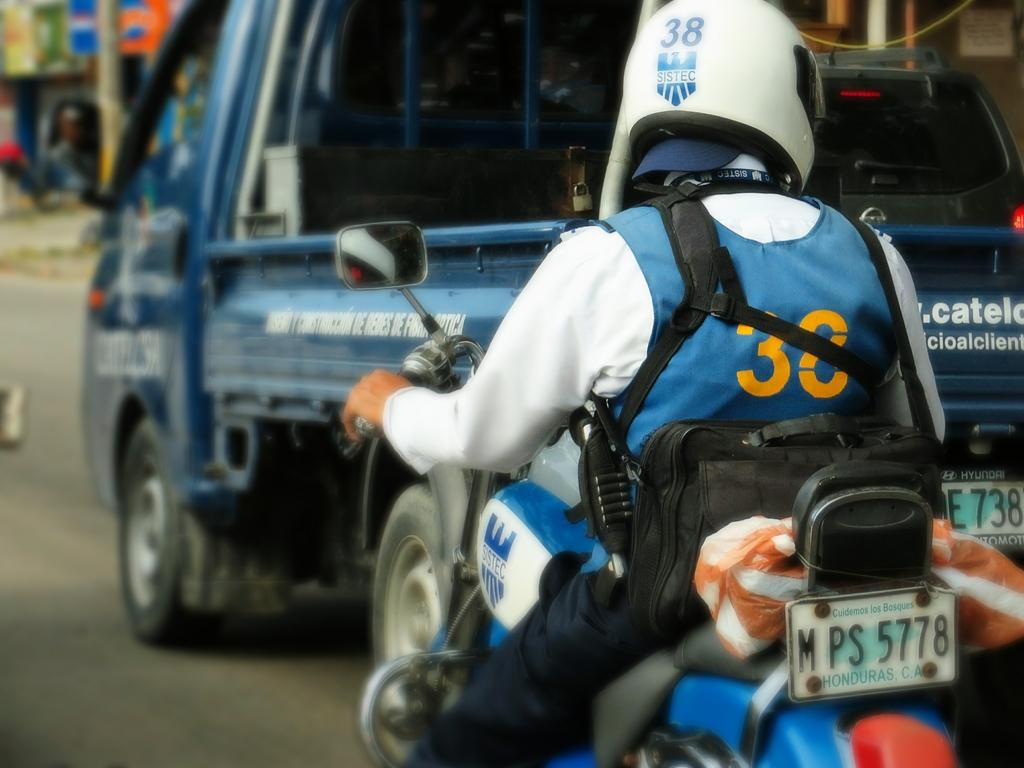What can be seen on the right side of the image? There is a person on the right side of the image. What is the person wearing? The person is wearing a white color shirt and a helmet. What activity is the person engaged in? The person is riding a bike. Where is the bike located? The bike is on a road. What else is present on the road? There is a vehicle on the road. How would you describe the background of the image? The background of the image is blurred. What type of corn can be seen growing on the side of the road in the image? There is no corn visible in the image; the focus is on the person riding a bike and the vehicle on the road. 